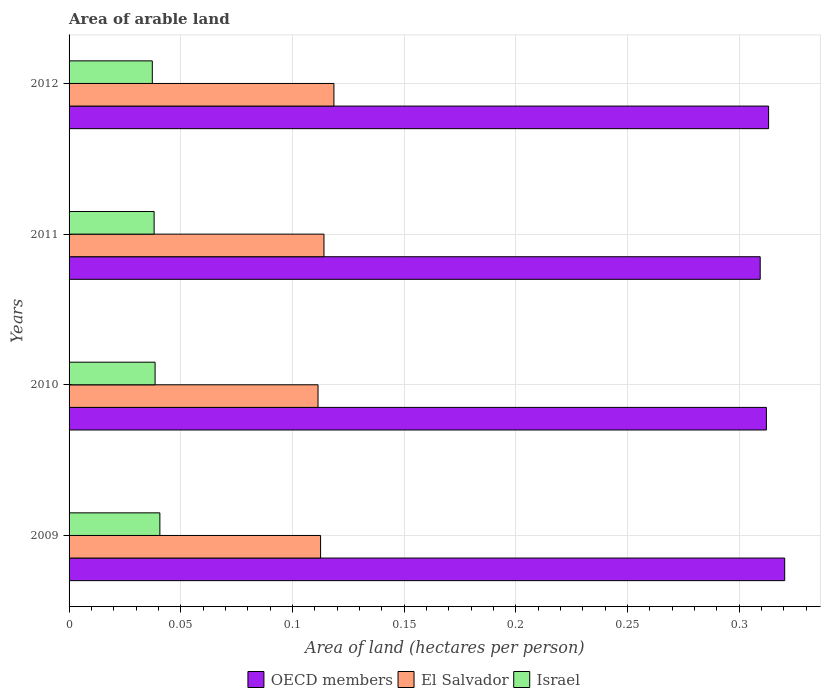How many groups of bars are there?
Offer a terse response. 4. Are the number of bars per tick equal to the number of legend labels?
Offer a terse response. Yes. Are the number of bars on each tick of the Y-axis equal?
Make the answer very short. Yes. How many bars are there on the 4th tick from the top?
Your answer should be compact. 3. What is the label of the 2nd group of bars from the top?
Your answer should be compact. 2011. What is the total arable land in OECD members in 2012?
Your answer should be very brief. 0.31. Across all years, what is the maximum total arable land in Israel?
Your answer should be very brief. 0.04. Across all years, what is the minimum total arable land in El Salvador?
Keep it short and to the point. 0.11. In which year was the total arable land in Israel maximum?
Provide a succinct answer. 2009. What is the total total arable land in OECD members in the graph?
Make the answer very short. 1.26. What is the difference between the total arable land in Israel in 2010 and that in 2011?
Keep it short and to the point. 0. What is the difference between the total arable land in Israel in 2011 and the total arable land in OECD members in 2012?
Provide a succinct answer. -0.28. What is the average total arable land in El Salvador per year?
Offer a very short reply. 0.11. In the year 2012, what is the difference between the total arable land in El Salvador and total arable land in OECD members?
Your response must be concise. -0.19. In how many years, is the total arable land in El Salvador greater than 0.04 hectares per person?
Provide a succinct answer. 4. What is the ratio of the total arable land in El Salvador in 2010 to that in 2012?
Offer a very short reply. 0.94. Is the total arable land in OECD members in 2009 less than that in 2010?
Your response must be concise. No. Is the difference between the total arable land in El Salvador in 2009 and 2011 greater than the difference between the total arable land in OECD members in 2009 and 2011?
Your response must be concise. No. What is the difference between the highest and the second highest total arable land in El Salvador?
Ensure brevity in your answer.  0. What is the difference between the highest and the lowest total arable land in El Salvador?
Offer a very short reply. 0.01. What does the 3rd bar from the top in 2010 represents?
Make the answer very short. OECD members. Is it the case that in every year, the sum of the total arable land in OECD members and total arable land in El Salvador is greater than the total arable land in Israel?
Keep it short and to the point. Yes. How many bars are there?
Provide a succinct answer. 12. Are the values on the major ticks of X-axis written in scientific E-notation?
Keep it short and to the point. No. Where does the legend appear in the graph?
Ensure brevity in your answer.  Bottom center. What is the title of the graph?
Your response must be concise. Area of arable land. What is the label or title of the X-axis?
Your answer should be compact. Area of land (hectares per person). What is the label or title of the Y-axis?
Your response must be concise. Years. What is the Area of land (hectares per person) in OECD members in 2009?
Make the answer very short. 0.32. What is the Area of land (hectares per person) of El Salvador in 2009?
Provide a short and direct response. 0.11. What is the Area of land (hectares per person) of Israel in 2009?
Your response must be concise. 0.04. What is the Area of land (hectares per person) in OECD members in 2010?
Make the answer very short. 0.31. What is the Area of land (hectares per person) in El Salvador in 2010?
Offer a terse response. 0.11. What is the Area of land (hectares per person) in Israel in 2010?
Ensure brevity in your answer.  0.04. What is the Area of land (hectares per person) of OECD members in 2011?
Keep it short and to the point. 0.31. What is the Area of land (hectares per person) of El Salvador in 2011?
Make the answer very short. 0.11. What is the Area of land (hectares per person) of Israel in 2011?
Ensure brevity in your answer.  0.04. What is the Area of land (hectares per person) of OECD members in 2012?
Provide a short and direct response. 0.31. What is the Area of land (hectares per person) in El Salvador in 2012?
Make the answer very short. 0.12. What is the Area of land (hectares per person) of Israel in 2012?
Ensure brevity in your answer.  0.04. Across all years, what is the maximum Area of land (hectares per person) in OECD members?
Provide a short and direct response. 0.32. Across all years, what is the maximum Area of land (hectares per person) of El Salvador?
Give a very brief answer. 0.12. Across all years, what is the maximum Area of land (hectares per person) in Israel?
Offer a very short reply. 0.04. Across all years, what is the minimum Area of land (hectares per person) of OECD members?
Give a very brief answer. 0.31. Across all years, what is the minimum Area of land (hectares per person) in El Salvador?
Your answer should be very brief. 0.11. Across all years, what is the minimum Area of land (hectares per person) in Israel?
Your answer should be compact. 0.04. What is the total Area of land (hectares per person) of OECD members in the graph?
Your response must be concise. 1.26. What is the total Area of land (hectares per person) of El Salvador in the graph?
Provide a succinct answer. 0.46. What is the total Area of land (hectares per person) in Israel in the graph?
Your answer should be very brief. 0.15. What is the difference between the Area of land (hectares per person) of OECD members in 2009 and that in 2010?
Your answer should be compact. 0.01. What is the difference between the Area of land (hectares per person) in El Salvador in 2009 and that in 2010?
Give a very brief answer. 0. What is the difference between the Area of land (hectares per person) in Israel in 2009 and that in 2010?
Give a very brief answer. 0. What is the difference between the Area of land (hectares per person) of OECD members in 2009 and that in 2011?
Your answer should be very brief. 0.01. What is the difference between the Area of land (hectares per person) in El Salvador in 2009 and that in 2011?
Ensure brevity in your answer.  -0. What is the difference between the Area of land (hectares per person) in Israel in 2009 and that in 2011?
Offer a terse response. 0. What is the difference between the Area of land (hectares per person) in OECD members in 2009 and that in 2012?
Your answer should be very brief. 0.01. What is the difference between the Area of land (hectares per person) of El Salvador in 2009 and that in 2012?
Keep it short and to the point. -0.01. What is the difference between the Area of land (hectares per person) in Israel in 2009 and that in 2012?
Offer a very short reply. 0. What is the difference between the Area of land (hectares per person) in OECD members in 2010 and that in 2011?
Your response must be concise. 0. What is the difference between the Area of land (hectares per person) of El Salvador in 2010 and that in 2011?
Keep it short and to the point. -0. What is the difference between the Area of land (hectares per person) of OECD members in 2010 and that in 2012?
Make the answer very short. -0. What is the difference between the Area of land (hectares per person) of El Salvador in 2010 and that in 2012?
Provide a short and direct response. -0.01. What is the difference between the Area of land (hectares per person) in Israel in 2010 and that in 2012?
Keep it short and to the point. 0. What is the difference between the Area of land (hectares per person) of OECD members in 2011 and that in 2012?
Offer a terse response. -0. What is the difference between the Area of land (hectares per person) of El Salvador in 2011 and that in 2012?
Your answer should be compact. -0. What is the difference between the Area of land (hectares per person) of Israel in 2011 and that in 2012?
Keep it short and to the point. 0. What is the difference between the Area of land (hectares per person) in OECD members in 2009 and the Area of land (hectares per person) in El Salvador in 2010?
Give a very brief answer. 0.21. What is the difference between the Area of land (hectares per person) of OECD members in 2009 and the Area of land (hectares per person) of Israel in 2010?
Provide a short and direct response. 0.28. What is the difference between the Area of land (hectares per person) in El Salvador in 2009 and the Area of land (hectares per person) in Israel in 2010?
Provide a short and direct response. 0.07. What is the difference between the Area of land (hectares per person) of OECD members in 2009 and the Area of land (hectares per person) of El Salvador in 2011?
Offer a terse response. 0.21. What is the difference between the Area of land (hectares per person) in OECD members in 2009 and the Area of land (hectares per person) in Israel in 2011?
Ensure brevity in your answer.  0.28. What is the difference between the Area of land (hectares per person) in El Salvador in 2009 and the Area of land (hectares per person) in Israel in 2011?
Give a very brief answer. 0.07. What is the difference between the Area of land (hectares per person) of OECD members in 2009 and the Area of land (hectares per person) of El Salvador in 2012?
Keep it short and to the point. 0.2. What is the difference between the Area of land (hectares per person) of OECD members in 2009 and the Area of land (hectares per person) of Israel in 2012?
Your answer should be very brief. 0.28. What is the difference between the Area of land (hectares per person) in El Salvador in 2009 and the Area of land (hectares per person) in Israel in 2012?
Ensure brevity in your answer.  0.08. What is the difference between the Area of land (hectares per person) in OECD members in 2010 and the Area of land (hectares per person) in El Salvador in 2011?
Offer a terse response. 0.2. What is the difference between the Area of land (hectares per person) of OECD members in 2010 and the Area of land (hectares per person) of Israel in 2011?
Your answer should be compact. 0.27. What is the difference between the Area of land (hectares per person) in El Salvador in 2010 and the Area of land (hectares per person) in Israel in 2011?
Offer a very short reply. 0.07. What is the difference between the Area of land (hectares per person) in OECD members in 2010 and the Area of land (hectares per person) in El Salvador in 2012?
Your response must be concise. 0.19. What is the difference between the Area of land (hectares per person) in OECD members in 2010 and the Area of land (hectares per person) in Israel in 2012?
Your answer should be very brief. 0.27. What is the difference between the Area of land (hectares per person) in El Salvador in 2010 and the Area of land (hectares per person) in Israel in 2012?
Offer a terse response. 0.07. What is the difference between the Area of land (hectares per person) in OECD members in 2011 and the Area of land (hectares per person) in El Salvador in 2012?
Provide a succinct answer. 0.19. What is the difference between the Area of land (hectares per person) of OECD members in 2011 and the Area of land (hectares per person) of Israel in 2012?
Your answer should be very brief. 0.27. What is the difference between the Area of land (hectares per person) in El Salvador in 2011 and the Area of land (hectares per person) in Israel in 2012?
Your answer should be very brief. 0.08. What is the average Area of land (hectares per person) in OECD members per year?
Give a very brief answer. 0.31. What is the average Area of land (hectares per person) in El Salvador per year?
Ensure brevity in your answer.  0.11. What is the average Area of land (hectares per person) of Israel per year?
Offer a very short reply. 0.04. In the year 2009, what is the difference between the Area of land (hectares per person) in OECD members and Area of land (hectares per person) in El Salvador?
Provide a succinct answer. 0.21. In the year 2009, what is the difference between the Area of land (hectares per person) in OECD members and Area of land (hectares per person) in Israel?
Give a very brief answer. 0.28. In the year 2009, what is the difference between the Area of land (hectares per person) in El Salvador and Area of land (hectares per person) in Israel?
Make the answer very short. 0.07. In the year 2010, what is the difference between the Area of land (hectares per person) of OECD members and Area of land (hectares per person) of El Salvador?
Give a very brief answer. 0.2. In the year 2010, what is the difference between the Area of land (hectares per person) in OECD members and Area of land (hectares per person) in Israel?
Provide a succinct answer. 0.27. In the year 2010, what is the difference between the Area of land (hectares per person) in El Salvador and Area of land (hectares per person) in Israel?
Provide a short and direct response. 0.07. In the year 2011, what is the difference between the Area of land (hectares per person) of OECD members and Area of land (hectares per person) of El Salvador?
Your answer should be very brief. 0.2. In the year 2011, what is the difference between the Area of land (hectares per person) in OECD members and Area of land (hectares per person) in Israel?
Give a very brief answer. 0.27. In the year 2011, what is the difference between the Area of land (hectares per person) of El Salvador and Area of land (hectares per person) of Israel?
Offer a very short reply. 0.08. In the year 2012, what is the difference between the Area of land (hectares per person) of OECD members and Area of land (hectares per person) of El Salvador?
Offer a very short reply. 0.19. In the year 2012, what is the difference between the Area of land (hectares per person) in OECD members and Area of land (hectares per person) in Israel?
Make the answer very short. 0.28. In the year 2012, what is the difference between the Area of land (hectares per person) of El Salvador and Area of land (hectares per person) of Israel?
Your response must be concise. 0.08. What is the ratio of the Area of land (hectares per person) in OECD members in 2009 to that in 2010?
Ensure brevity in your answer.  1.03. What is the ratio of the Area of land (hectares per person) of El Salvador in 2009 to that in 2010?
Give a very brief answer. 1.01. What is the ratio of the Area of land (hectares per person) of Israel in 2009 to that in 2010?
Provide a succinct answer. 1.06. What is the ratio of the Area of land (hectares per person) in OECD members in 2009 to that in 2011?
Your answer should be compact. 1.04. What is the ratio of the Area of land (hectares per person) of El Salvador in 2009 to that in 2011?
Your answer should be compact. 0.99. What is the ratio of the Area of land (hectares per person) of Israel in 2009 to that in 2011?
Keep it short and to the point. 1.07. What is the ratio of the Area of land (hectares per person) of El Salvador in 2009 to that in 2012?
Provide a succinct answer. 0.95. What is the ratio of the Area of land (hectares per person) of Israel in 2009 to that in 2012?
Your answer should be compact. 1.09. What is the ratio of the Area of land (hectares per person) of OECD members in 2010 to that in 2011?
Offer a very short reply. 1.01. What is the ratio of the Area of land (hectares per person) in El Salvador in 2010 to that in 2011?
Make the answer very short. 0.98. What is the ratio of the Area of land (hectares per person) of Israel in 2010 to that in 2011?
Your answer should be compact. 1.01. What is the ratio of the Area of land (hectares per person) of OECD members in 2010 to that in 2012?
Give a very brief answer. 1. What is the ratio of the Area of land (hectares per person) in Israel in 2010 to that in 2012?
Provide a short and direct response. 1.03. What is the ratio of the Area of land (hectares per person) of OECD members in 2011 to that in 2012?
Provide a succinct answer. 0.99. What is the ratio of the Area of land (hectares per person) of El Salvador in 2011 to that in 2012?
Provide a short and direct response. 0.96. What is the ratio of the Area of land (hectares per person) in Israel in 2011 to that in 2012?
Keep it short and to the point. 1.02. What is the difference between the highest and the second highest Area of land (hectares per person) in OECD members?
Offer a terse response. 0.01. What is the difference between the highest and the second highest Area of land (hectares per person) of El Salvador?
Your answer should be very brief. 0. What is the difference between the highest and the second highest Area of land (hectares per person) of Israel?
Provide a short and direct response. 0. What is the difference between the highest and the lowest Area of land (hectares per person) of OECD members?
Provide a succinct answer. 0.01. What is the difference between the highest and the lowest Area of land (hectares per person) in El Salvador?
Your answer should be very brief. 0.01. What is the difference between the highest and the lowest Area of land (hectares per person) of Israel?
Make the answer very short. 0. 